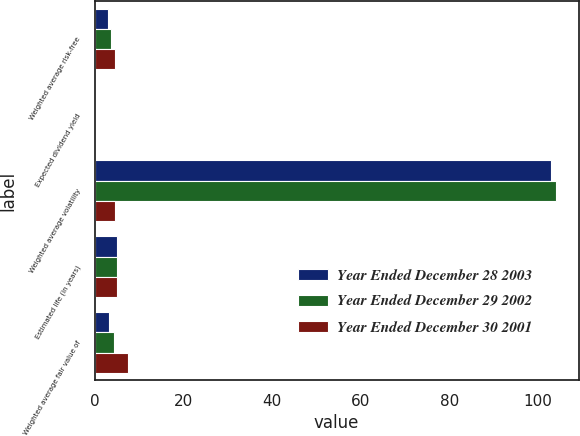<chart> <loc_0><loc_0><loc_500><loc_500><stacked_bar_chart><ecel><fcel>Weighted average risk-free<fcel>Expected dividend yield<fcel>Weighted average volatility<fcel>Estimated life (in years)<fcel>Weighted average fair value of<nl><fcel>Year Ended December 28 2003<fcel>3.03<fcel>0<fcel>103<fcel>5<fcel>3.31<nl><fcel>Year Ended December 29 2002<fcel>3.73<fcel>0<fcel>104<fcel>5<fcel>4.39<nl><fcel>Year Ended December 30 2001<fcel>4.65<fcel>0<fcel>4.52<fcel>5<fcel>7.51<nl></chart> 